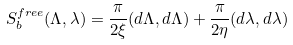<formula> <loc_0><loc_0><loc_500><loc_500>S _ { b } ^ { f r e e } ( \Lambda , \lambda ) = \frac { \pi } { 2 \xi } ( d \Lambda , d \Lambda ) + \frac { \pi } { 2 \eta } ( d \lambda , d \lambda )</formula> 